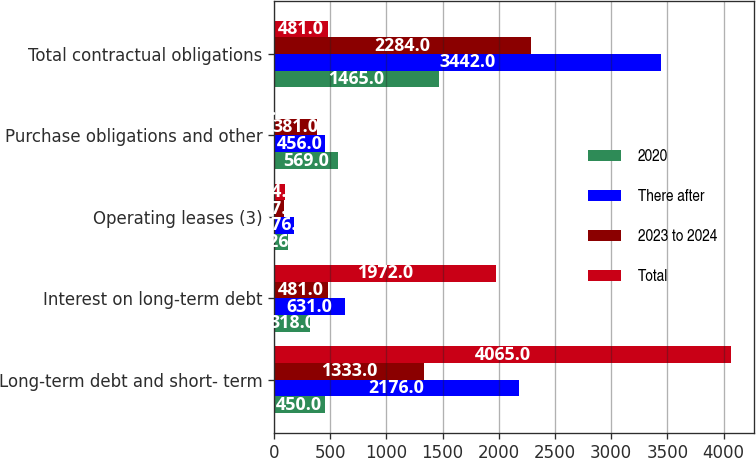Convert chart. <chart><loc_0><loc_0><loc_500><loc_500><stacked_bar_chart><ecel><fcel>Long-term debt and short- term<fcel>Interest on long-term debt<fcel>Operating leases (3)<fcel>Purchase obligations and other<fcel>Total contractual obligations<nl><fcel>2020<fcel>450<fcel>318<fcel>126<fcel>569<fcel>1465<nl><fcel>There after<fcel>2176<fcel>631<fcel>176<fcel>456<fcel>3442<nl><fcel>2023 to 2024<fcel>1333<fcel>481<fcel>87<fcel>381<fcel>2284<nl><fcel>Total<fcel>4065<fcel>1972<fcel>94<fcel>8<fcel>481<nl></chart> 